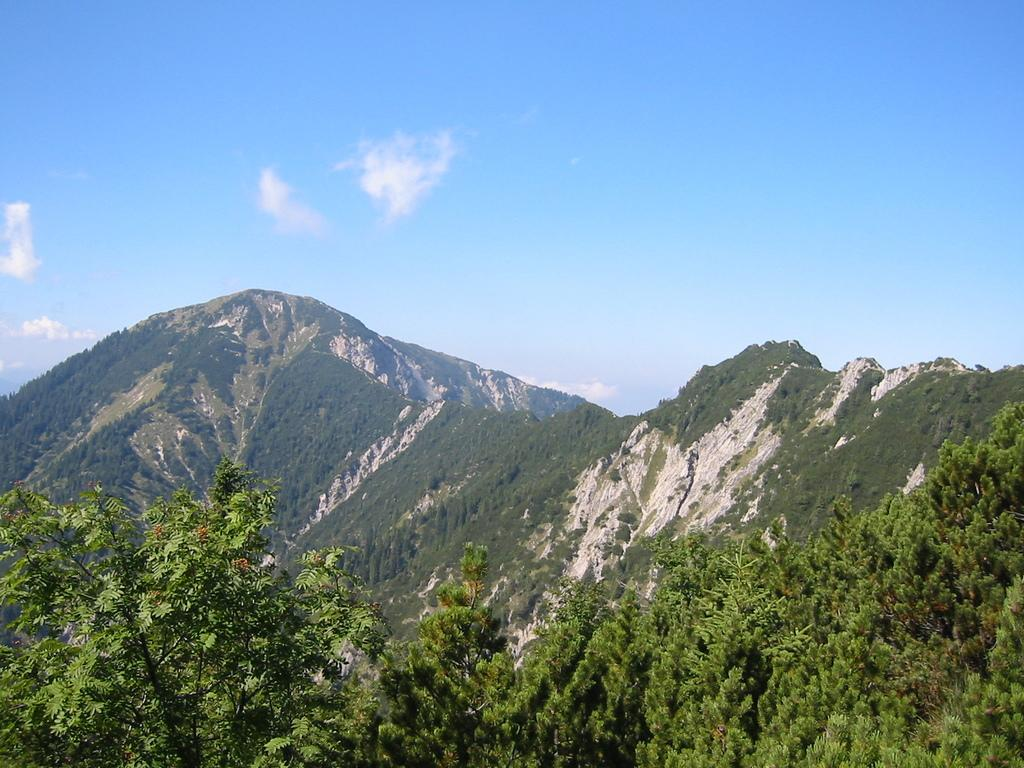What type of natural landscape can be seen in the image? There are mountains, grass, trees, and plants visible in the image. What part of the natural environment is visible in the image? The sky is visible in the image, and clouds are present in the sky. Can you describe the vegetation in the image? There is grass, trees, and plants visible in the image. Is there a bathtub visible in the image? No, there is no bathtub present in the image. Can you tell me how many people are swimming in the image? There is no swimming or water activity depicted in the image; it features a natural landscape with mountains, grass, trees, plants, and a sky with clouds. 